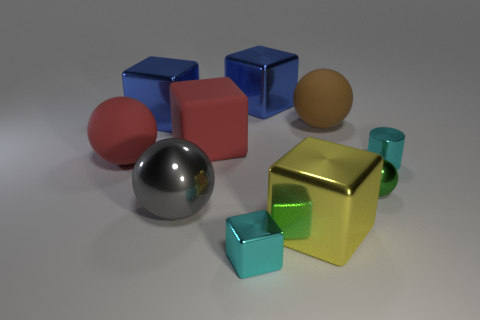Subtract all large spheres. How many spheres are left? 1 Subtract all cyan cylinders. How many blue blocks are left? 2 Subtract all blue blocks. How many blocks are left? 3 Subtract all gray blocks. Subtract all gray spheres. How many blocks are left? 5 Subtract all balls. How many objects are left? 6 Subtract all large yellow metal objects. Subtract all brown rubber spheres. How many objects are left? 8 Add 9 cyan cylinders. How many cyan cylinders are left? 10 Add 1 blue objects. How many blue objects exist? 3 Subtract 1 brown spheres. How many objects are left? 9 